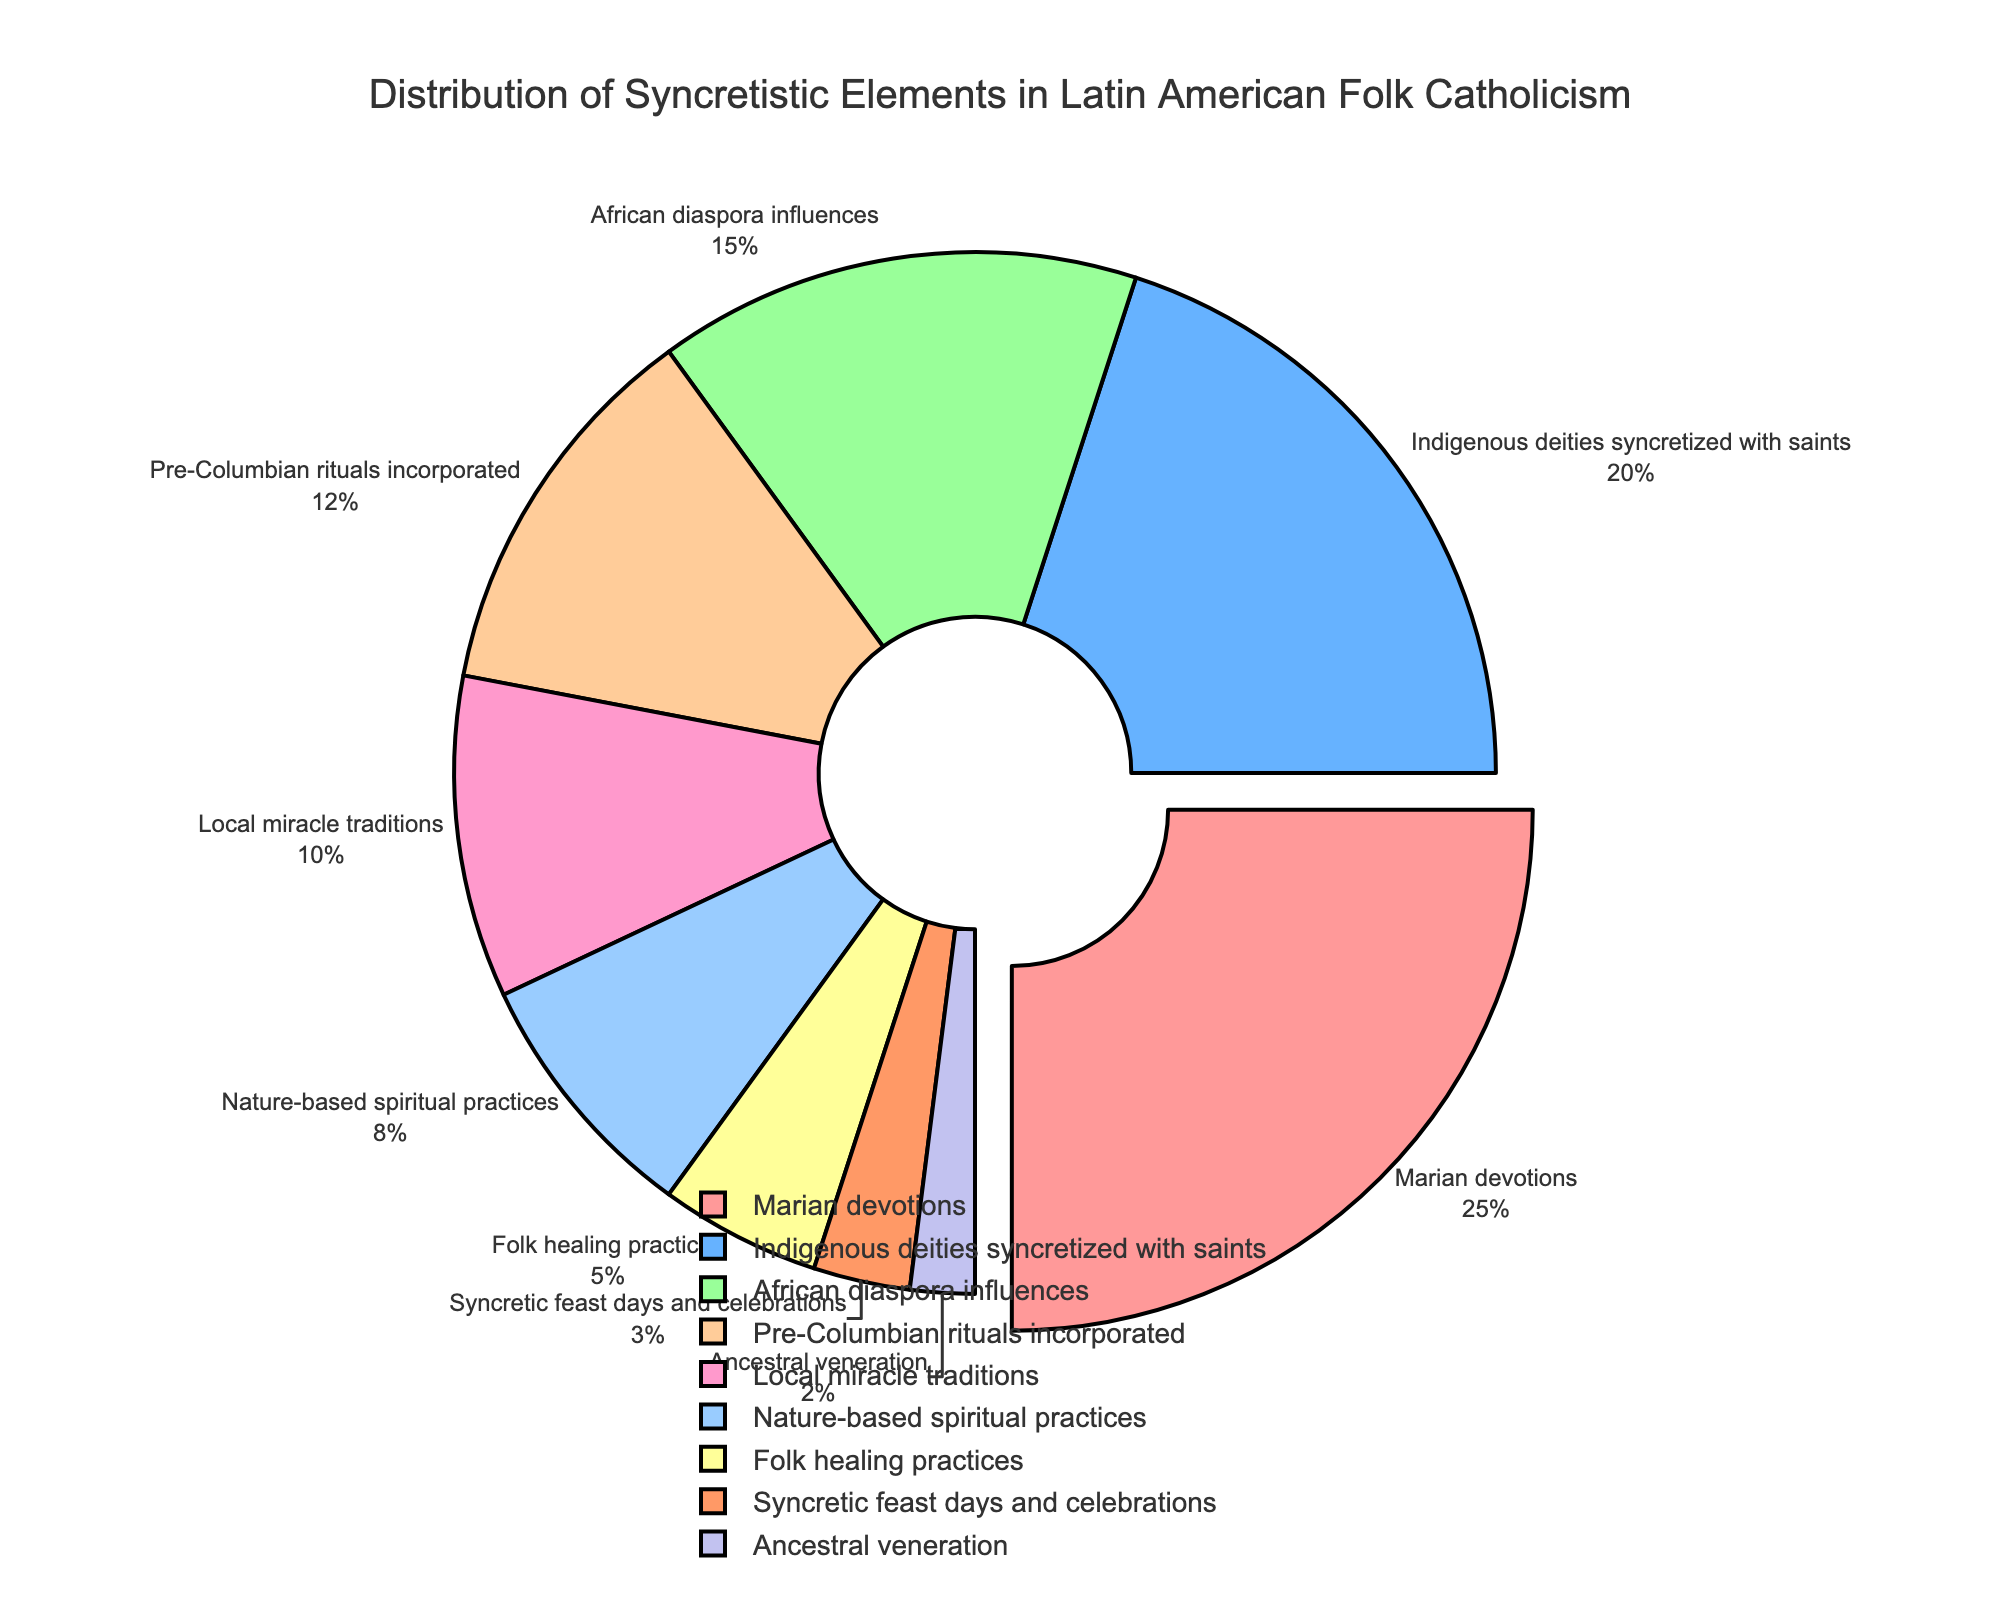Marian devotions show the highest proportion in the distribution. By how much percentage are Marian devotions higher than African diaspora influences? First, identify the percentage values of Marian devotions (25%) and African diaspora influences (15%). Then, calculate the difference between them: 25% - 15% = 10%. Therefore, Marian devotions are higher by 10% compared to African diaspora influences.
Answer: 10% How many elements are represented in the pie chart? Count the number of unique elements listed in the provided data. The elements are Marian devotions, Indigenous deities syncretized with saints, African diaspora influences, Pre-Columbian rituals incorporated, Local miracle traditions, Nature-based spiritual practices, Folk healing practices, Syncretic feast days and celebrations, and Ancestral veneration, which totals to 9.
Answer: 9 What is the combined percentage of Indigenous deities syncretized with saints and Pre-Columbian rituals incorporated? Add the percentage values of the two elements: Indigenous deities syncretized with saints (20%) and Pre-Columbian rituals incorporated (12%). Therefore, the combined percentage is 20% + 12% = 32%.
Answer: 32% Which element has the smallest proportion in the distribution and what is its percentage? Identify the element with the smallest percentage value from the provided data: Ancestral veneration with 2%.
Answer: Ancestral veneration, 2% Which color represents Local miracle traditions in the chart? Locate the color assigned to Local miracle traditions in the pie chart. According to the provided color sequence, Local miracle traditions are represented by orange (#FF9966).
Answer: Orange Calculate the total percentage covered by Nature-based spiritual practices and Folk healing practices. Add the percentage values of Nature-based spiritual practices (8%) and Folk healing practices (5%). Therefore, the total percentage is 8% + 5% = 13%.
Answer: 13% How does the percentage of Syncretic feast days and celebrations compare to that of Nature-based spiritual practices? The percentage for Syncretic feast days and celebrations is 3%, whereas for Nature-based spiritual practices it is 8%. Since 3% is less than 8%, Syncretic feast days and celebrations have a smaller proportion than Nature-based spiritual practices.
Answer: Smaller proportion What percentage of the distribution is covered by elements that are directly influenced by indigenous traditions (Indigenous deities syncretized with saints and Pre-Columbian rituals incorporated)? Sum the percentages of Indigenous deities syncretized with saints (20%) and Pre-Columbian rituals incorporated (12%). Therefore, the cumulative influence is 20% + 12% = 32%.
Answer: 32% Is the percentage of African diaspora influences larger or smaller than the percentage of Local miracle traditions? The percentage for African diaspora influences is 15%, whereas for Local miracle traditions it is 10%. Since 15% is larger than 10%, African diaspora influences have a larger proportion.
Answer: Larger Which element is pulled out (emphasized) in the pie chart and why? The element with the highest percentage is typically pulled out to emphasize its significance. Here, Marian devotions with 25% is pulled out.
Answer: Marian devotions 